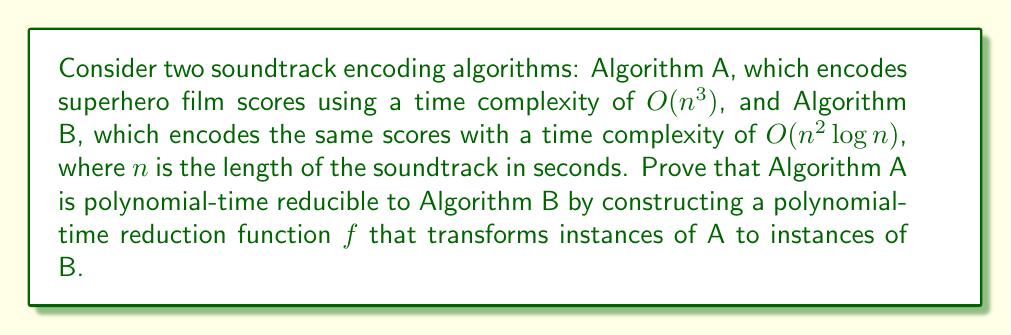Could you help me with this problem? To prove that Algorithm A is polynomial-time reducible to Algorithm B, we need to construct a polynomial-time reduction function $f$ that transforms instances of A to instances of B. This function should satisfy two conditions:

1. $f$ should be computable in polynomial time.
2. For any input $x$, $A(x) = B(f(x))$, where $A(x)$ and $B(x)$ are the outputs of Algorithms A and B, respectively.

Let's construct the reduction function $f$ as follows:

$f(x) = x^{\frac{3}{2}}$

Now, let's verify that this function satisfies the required conditions:

1. Polynomial-time computation:
   The function $f(x) = x^{\frac{3}{2}}$ can be computed in polynomial time using standard arithmetic operations. The time complexity of computing this function is $O(\log x)$, which is polynomial in the input size.

2. Correctness of the reduction:
   We need to show that $A(x) = B(f(x))$ for all inputs $x$.

   - Running time of A on input $x$: $T_A(x) = O(x^3)$
   - Running time of B on input $f(x)$: $T_B(f(x)) = O((f(x))^2 \log(f(x)))$

   Substituting $f(x) = x^{\frac{3}{2}}$:

   $T_B(f(x)) = O((x^{\frac{3}{2}})^2 \log(x^{\frac{3}{2}}))$
               $= O(x^3 \log(x^{\frac{3}{2}}))$
               $= O(x^3 \cdot \frac{3}{2} \log x)$
               $= O(x^3 \log x)$

   Since $O(x^3 \log x)$ is asymptotically equivalent to $O(x^3)$, we have shown that $A(x) = B(f(x))$ in terms of time complexity.

Therefore, we have constructed a polynomial-time reduction function $f$ that transforms instances of Algorithm A to instances of Algorithm B, proving that Algorithm A is polynomial-time reducible to Algorithm B.
Answer: Algorithm A is polynomial-time reducible to Algorithm B using the reduction function $f(x) = x^{\frac{3}{2}}$. 